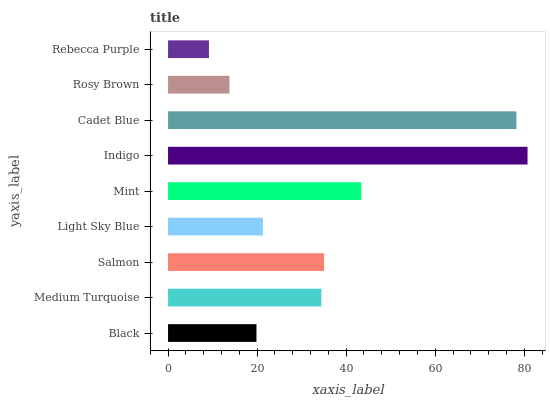Is Rebecca Purple the minimum?
Answer yes or no. Yes. Is Indigo the maximum?
Answer yes or no. Yes. Is Medium Turquoise the minimum?
Answer yes or no. No. Is Medium Turquoise the maximum?
Answer yes or no. No. Is Medium Turquoise greater than Black?
Answer yes or no. Yes. Is Black less than Medium Turquoise?
Answer yes or no. Yes. Is Black greater than Medium Turquoise?
Answer yes or no. No. Is Medium Turquoise less than Black?
Answer yes or no. No. Is Medium Turquoise the high median?
Answer yes or no. Yes. Is Medium Turquoise the low median?
Answer yes or no. Yes. Is Cadet Blue the high median?
Answer yes or no. No. Is Black the low median?
Answer yes or no. No. 